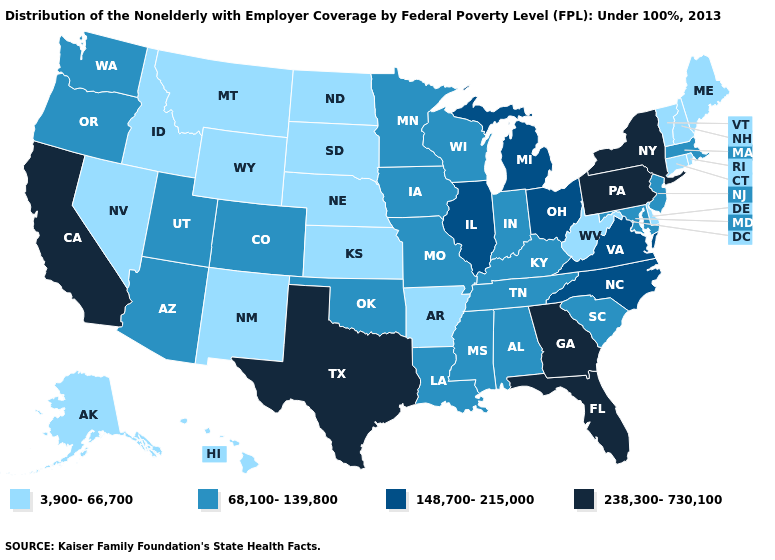Among the states that border New Hampshire , which have the highest value?
Answer briefly. Massachusetts. Does Wisconsin have the highest value in the MidWest?
Be succinct. No. Does the first symbol in the legend represent the smallest category?
Quick response, please. Yes. Is the legend a continuous bar?
Be succinct. No. What is the value of Connecticut?
Concise answer only. 3,900-66,700. Among the states that border Kentucky , does Missouri have the highest value?
Answer briefly. No. Among the states that border Oregon , which have the lowest value?
Give a very brief answer. Idaho, Nevada. How many symbols are there in the legend?
Write a very short answer. 4. What is the value of Oklahoma?
Answer briefly. 68,100-139,800. Does the map have missing data?
Keep it brief. No. Which states have the lowest value in the MidWest?
Keep it brief. Kansas, Nebraska, North Dakota, South Dakota. What is the lowest value in states that border Virginia?
Be succinct. 3,900-66,700. Does the map have missing data?
Concise answer only. No. Does the map have missing data?
Write a very short answer. No. Does Pennsylvania have the highest value in the Northeast?
Concise answer only. Yes. 